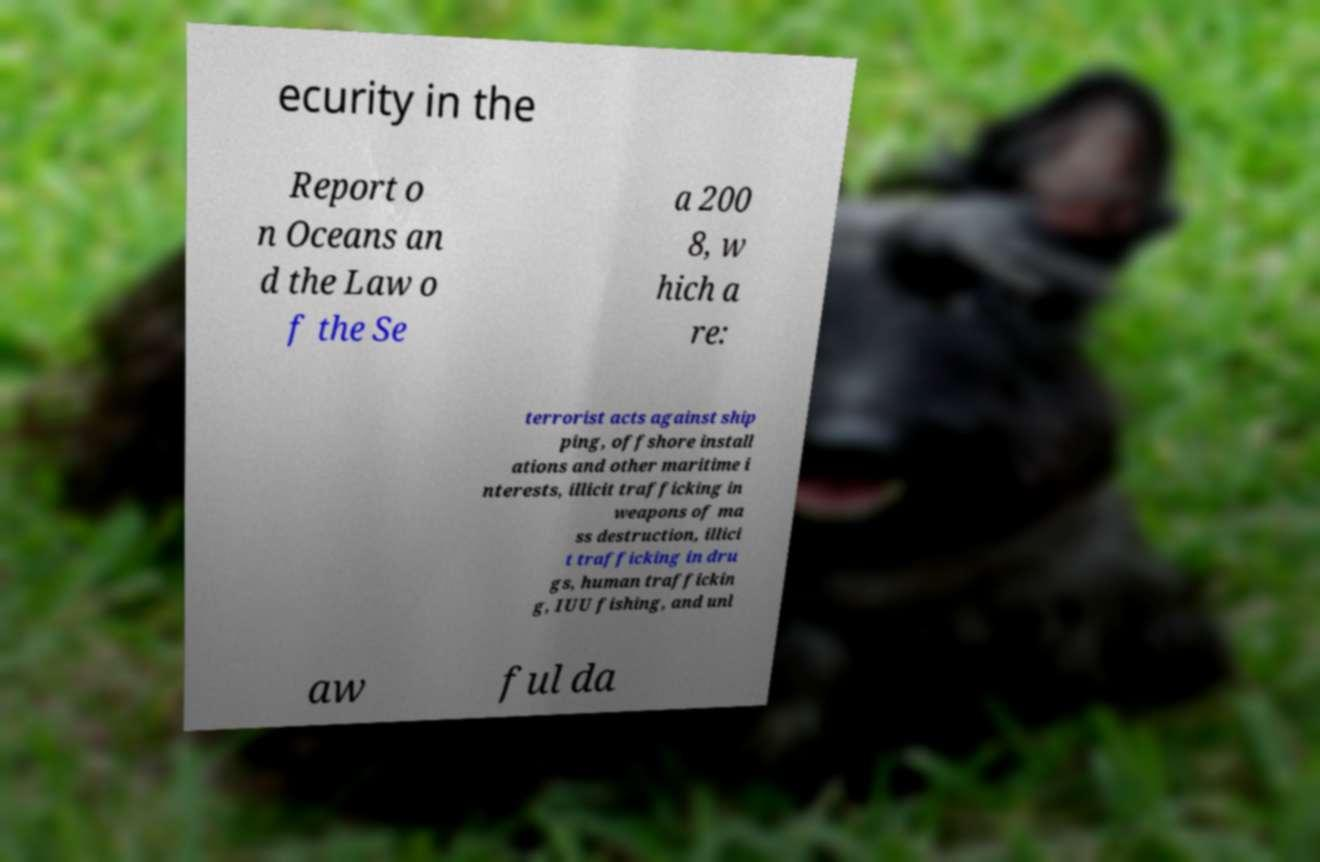Please identify and transcribe the text found in this image. ecurity in the Report o n Oceans an d the Law o f the Se a 200 8, w hich a re: terrorist acts against ship ping, offshore install ations and other maritime i nterests, illicit trafficking in weapons of ma ss destruction, illici t trafficking in dru gs, human traffickin g, IUU fishing, and unl aw ful da 